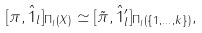<formula> <loc_0><loc_0><loc_500><loc_500>[ \pi , \hat { 1 } _ { l } ] _ { \Pi _ { l } ( X ) } & \simeq [ \tilde { \pi } , \hat { 1 } _ { l } ^ { \prime } ] _ { \Pi _ { l } ( \{ 1 , \dots , k \} ) } ,</formula> 